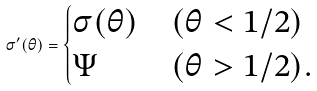Convert formula to latex. <formula><loc_0><loc_0><loc_500><loc_500>\sigma ^ { \prime } ( \theta ) = \begin{cases} \sigma ( \theta ) & ( \theta < 1 / 2 ) \\ \Psi & ( \theta > 1 / 2 ) . \end{cases}</formula> 